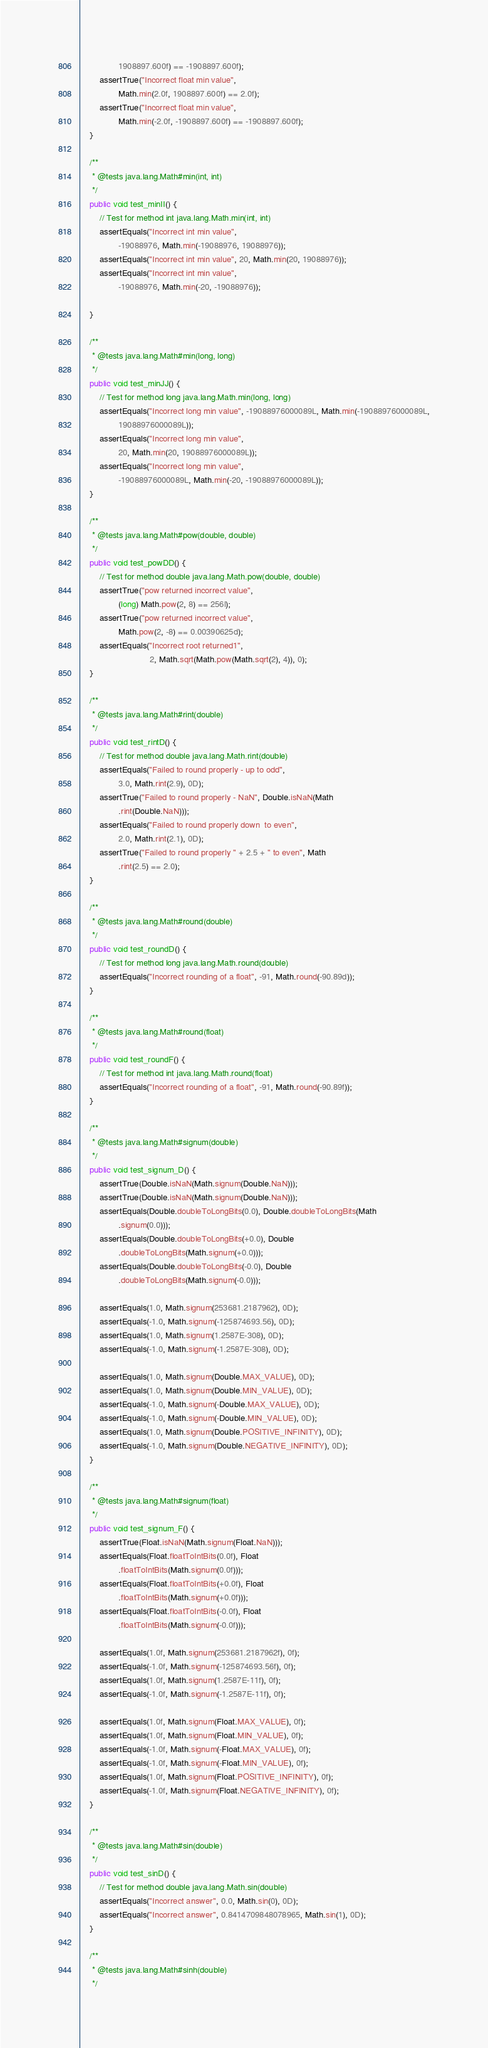Convert code to text. <code><loc_0><loc_0><loc_500><loc_500><_Java_>                1908897.600f) == -1908897.600f);
        assertTrue("Incorrect float min value",
                Math.min(2.0f, 1908897.600f) == 2.0f);
        assertTrue("Incorrect float min value",
                Math.min(-2.0f, -1908897.600f) == -1908897.600f);
    }

    /**
     * @tests java.lang.Math#min(int, int)
     */
    public void test_minII() {
        // Test for method int java.lang.Math.min(int, int)
        assertEquals("Incorrect int min value",
                -19088976, Math.min(-19088976, 19088976));
        assertEquals("Incorrect int min value", 20, Math.min(20, 19088976));
        assertEquals("Incorrect int min value",
                -19088976, Math.min(-20, -19088976));

    }

    /**
     * @tests java.lang.Math#min(long, long)
     */
    public void test_minJJ() {
        // Test for method long java.lang.Math.min(long, long)
        assertEquals("Incorrect long min value", -19088976000089L, Math.min(-19088976000089L,
                19088976000089L));
        assertEquals("Incorrect long min value",
                20, Math.min(20, 19088976000089L));
        assertEquals("Incorrect long min value",
                -19088976000089L, Math.min(-20, -19088976000089L));
    }

    /**
     * @tests java.lang.Math#pow(double, double)
     */
    public void test_powDD() {
        // Test for method double java.lang.Math.pow(double, double)
        assertTrue("pow returned incorrect value",
                (long) Math.pow(2, 8) == 256l);
        assertTrue("pow returned incorrect value",
                Math.pow(2, -8) == 0.00390625d);
        assertEquals("Incorrect root returned1",
                             2, Math.sqrt(Math.pow(Math.sqrt(2), 4)), 0);
    }

    /**
     * @tests java.lang.Math#rint(double)
     */
    public void test_rintD() {
        // Test for method double java.lang.Math.rint(double)
        assertEquals("Failed to round properly - up to odd",
                3.0, Math.rint(2.9), 0D);
        assertTrue("Failed to round properly - NaN", Double.isNaN(Math
                .rint(Double.NaN)));
        assertEquals("Failed to round properly down  to even",
                2.0, Math.rint(2.1), 0D);
        assertTrue("Failed to round properly " + 2.5 + " to even", Math
                .rint(2.5) == 2.0);
    }

    /**
     * @tests java.lang.Math#round(double)
     */
    public void test_roundD() {
        // Test for method long java.lang.Math.round(double)
        assertEquals("Incorrect rounding of a float", -91, Math.round(-90.89d));
    }

    /**
     * @tests java.lang.Math#round(float)
     */
    public void test_roundF() {
        // Test for method int java.lang.Math.round(float)
        assertEquals("Incorrect rounding of a float", -91, Math.round(-90.89f));
    }
    
    /**
     * @tests java.lang.Math#signum(double)
     */
    public void test_signum_D() {
        assertTrue(Double.isNaN(Math.signum(Double.NaN)));
        assertTrue(Double.isNaN(Math.signum(Double.NaN)));
        assertEquals(Double.doubleToLongBits(0.0), Double.doubleToLongBits(Math
                .signum(0.0)));
        assertEquals(Double.doubleToLongBits(+0.0), Double
                .doubleToLongBits(Math.signum(+0.0)));
        assertEquals(Double.doubleToLongBits(-0.0), Double
                .doubleToLongBits(Math.signum(-0.0)));

        assertEquals(1.0, Math.signum(253681.2187962), 0D);
        assertEquals(-1.0, Math.signum(-125874693.56), 0D);
        assertEquals(1.0, Math.signum(1.2587E-308), 0D);
        assertEquals(-1.0, Math.signum(-1.2587E-308), 0D);

        assertEquals(1.0, Math.signum(Double.MAX_VALUE), 0D);
        assertEquals(1.0, Math.signum(Double.MIN_VALUE), 0D);
        assertEquals(-1.0, Math.signum(-Double.MAX_VALUE), 0D);
        assertEquals(-1.0, Math.signum(-Double.MIN_VALUE), 0D);
        assertEquals(1.0, Math.signum(Double.POSITIVE_INFINITY), 0D);
        assertEquals(-1.0, Math.signum(Double.NEGATIVE_INFINITY), 0D);
    }

    /**
     * @tests java.lang.Math#signum(float)
     */
    public void test_signum_F() {
        assertTrue(Float.isNaN(Math.signum(Float.NaN)));
        assertEquals(Float.floatToIntBits(0.0f), Float
                .floatToIntBits(Math.signum(0.0f)));
        assertEquals(Float.floatToIntBits(+0.0f), Float
                .floatToIntBits(Math.signum(+0.0f)));
        assertEquals(Float.floatToIntBits(-0.0f), Float
                .floatToIntBits(Math.signum(-0.0f)));

        assertEquals(1.0f, Math.signum(253681.2187962f), 0f);
        assertEquals(-1.0f, Math.signum(-125874693.56f), 0f);
        assertEquals(1.0f, Math.signum(1.2587E-11f), 0f);
        assertEquals(-1.0f, Math.signum(-1.2587E-11f), 0f);

        assertEquals(1.0f, Math.signum(Float.MAX_VALUE), 0f);
        assertEquals(1.0f, Math.signum(Float.MIN_VALUE), 0f);
        assertEquals(-1.0f, Math.signum(-Float.MAX_VALUE), 0f);
        assertEquals(-1.0f, Math.signum(-Float.MIN_VALUE), 0f);
        assertEquals(1.0f, Math.signum(Float.POSITIVE_INFINITY), 0f);
        assertEquals(-1.0f, Math.signum(Float.NEGATIVE_INFINITY), 0f);
    }

    /**
     * @tests java.lang.Math#sin(double)
     */
    public void test_sinD() {
        // Test for method double java.lang.Math.sin(double)
        assertEquals("Incorrect answer", 0.0, Math.sin(0), 0D);
        assertEquals("Incorrect answer", 0.8414709848078965, Math.sin(1), 0D);
    }
    
    /**
     * @tests java.lang.Math#sinh(double)
     */</code> 